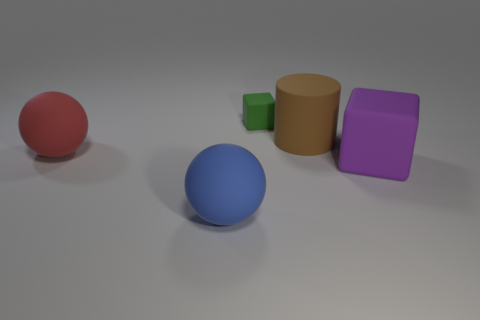Add 4 small green objects. How many objects exist? 9 Subtract 1 cylinders. How many cylinders are left? 0 Subtract all blue balls. How many balls are left? 1 Subtract all gray cylinders. Subtract all gray balls. How many cylinders are left? 1 Subtract all purple rubber objects. Subtract all big objects. How many objects are left? 0 Add 2 big rubber blocks. How many big rubber blocks are left? 3 Add 2 brown cylinders. How many brown cylinders exist? 3 Subtract 1 blue balls. How many objects are left? 4 Subtract all spheres. How many objects are left? 3 